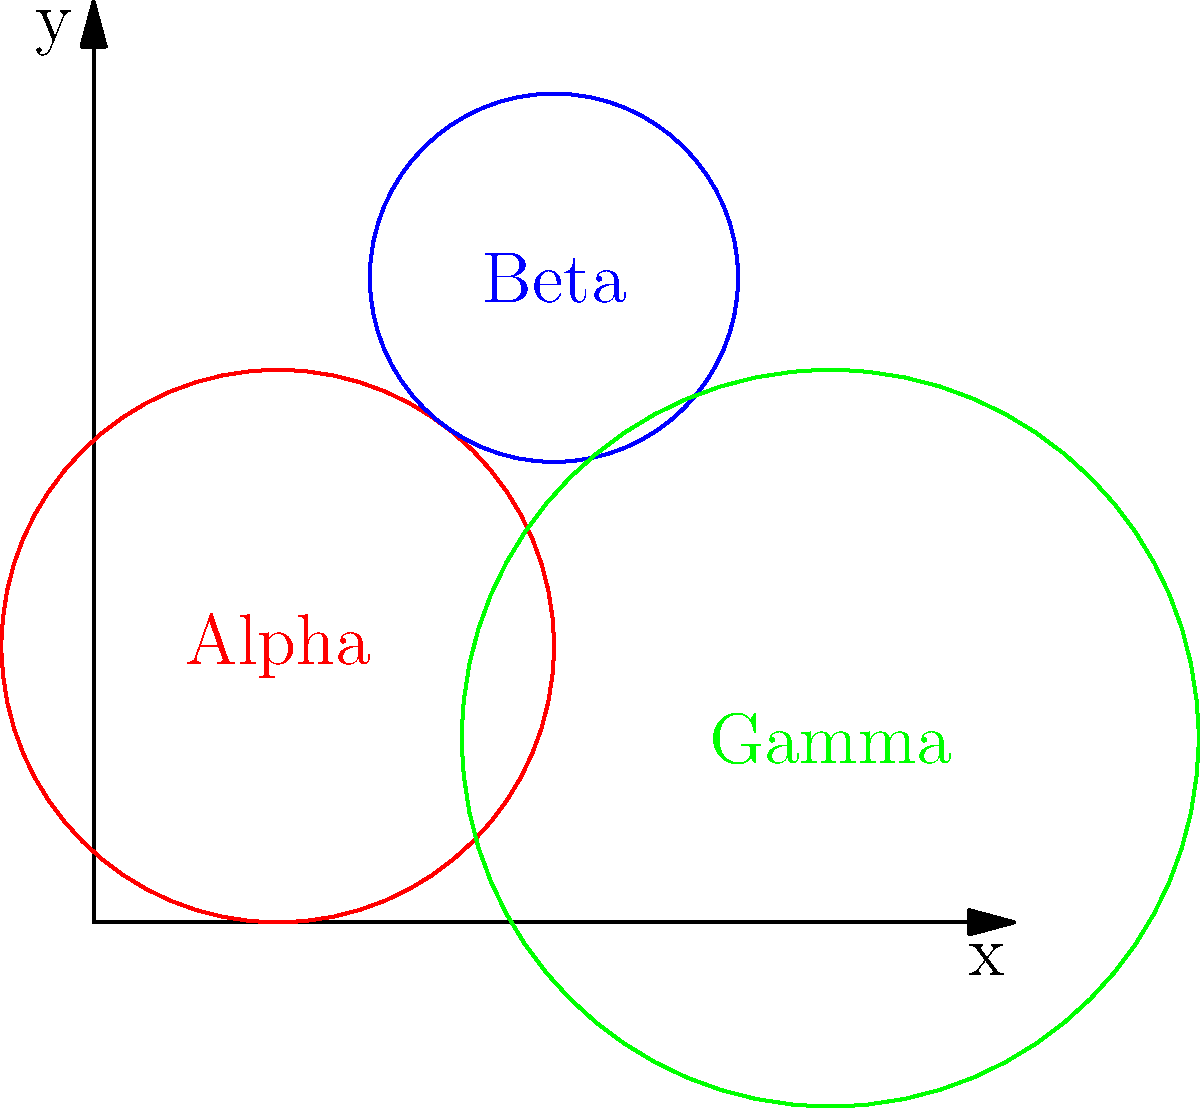In a strategic alliance-building game, three factions (Alpha, Beta, and Gamma) are vying for territorial control. Their areas of influence are represented by circles on the map above. The coordinates of the faction centers and their respective radii of influence are:

Alpha: (2, 3) with radius 3
Beta: (5, 7) with radius 2
Gamma: (8, 2) with radius 4

Calculate the total area of influence for all three factions combined. Round your answer to the nearest whole number. To solve this problem, we need to follow these steps:

1. Calculate the area of each faction's circle of influence:
   The formula for the area of a circle is $A = \pi r^2$

   Alpha: $A_\alpha = \pi (3^2) = 9\pi$
   Beta: $A_\beta = \pi (2^2) = 4\pi$
   Gamma: $A_\gamma = \pi (4^2) = 16\pi$

2. Sum up the areas:
   $A_{\text{total}} = A_\alpha + A_\beta + A_\gamma$
   $A_{\text{total}} = 9\pi + 4\pi + 16\pi = 29\pi$

3. Convert to a numerical value:
   $A_{\text{total}} = 29 \times 3.14159 \approx 91.1061$

4. Round to the nearest whole number:
   $A_{\text{total}} \approx 91$

Therefore, the total area of influence for all three factions combined is approximately 91 square units.
Answer: 91 square units 